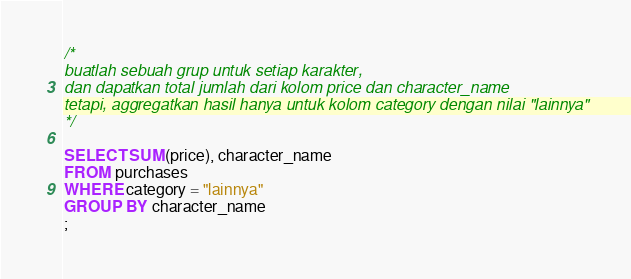<code> <loc_0><loc_0><loc_500><loc_500><_SQL_>/*
buatlah sebuah grup untuk setiap karakter,
dan dapatkan total jumlah dari kolom price dan character_name 
tetapi, aggregatkan hasil hanya untuk kolom category dengan nilai "lainnya"
*/

SELECT SUM(price), character_name
FROM purchases
WHERE category = "lainnya"
GROUP BY character_name
;

</code> 